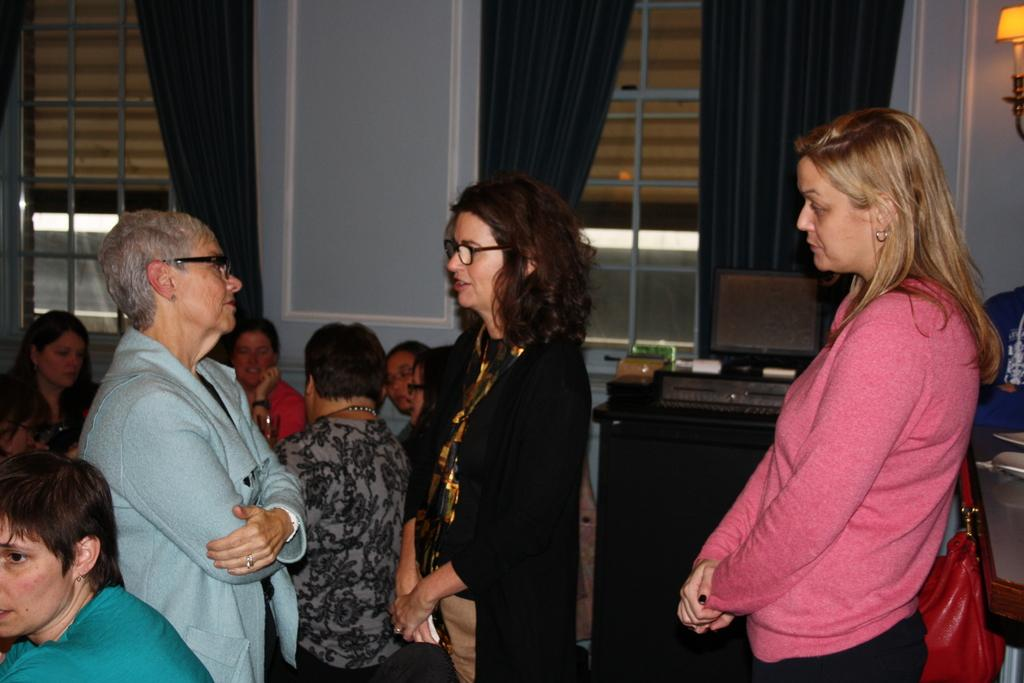What is happening in the image? There are people standing in the image. What can be seen in the background of the image? There are windows in the image. What type of window treatment is visible in the image? There are curtains visible in the image. What type of army uniform can be seen on the people in the image? There is no army uniform visible in the image; the people are not wearing any specific attire. What type of collar is visible on the people in the image? There is no collar visible on the people in the image, as they are not wearing any clothing that would have a collar. 